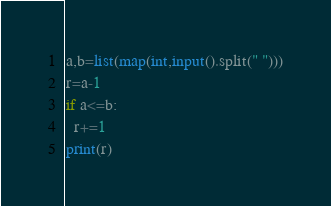<code> <loc_0><loc_0><loc_500><loc_500><_Python_>a,b=list(map(int,input().split(" ")))
r=a-1
if a<=b:
  r+=1
print(r)</code> 